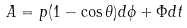Convert formula to latex. <formula><loc_0><loc_0><loc_500><loc_500>A = p ( 1 - \cos \theta ) d \phi + \Phi d t</formula> 